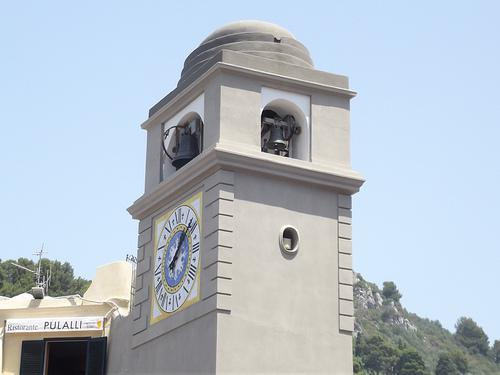Question: what time is shown on the clock?
Choices:
A. 11:15.
B. 4:23.
C. 1:08.
D. 6:54.
Answer with the letter. Answer: C Question: where are the trees?
Choices:
A. Next to the store.
B. By the bus.
C. Background.
D. Behind the trains.
Answer with the letter. Answer: C 